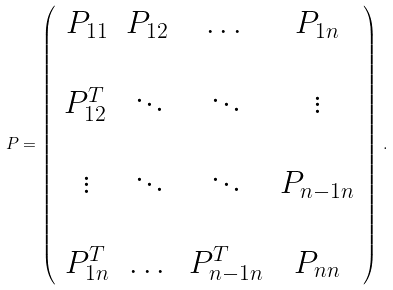Convert formula to latex. <formula><loc_0><loc_0><loc_500><loc_500>P = \left ( \begin{array} { c c c c } P _ { 1 1 } & P _ { 1 2 \, } & \dots & P _ { 1 n } \\ & & & \\ P _ { 1 2 \, } ^ { T } & \ddots & \ddots & \vdots \\ & & & \\ \vdots & \ddots & \ddots & P _ { n - 1 n } \\ & & & \\ P _ { 1 n } ^ { T } & \dots & P _ { n - 1 n } ^ { T } & P _ { n n } \end{array} \right ) \, .</formula> 